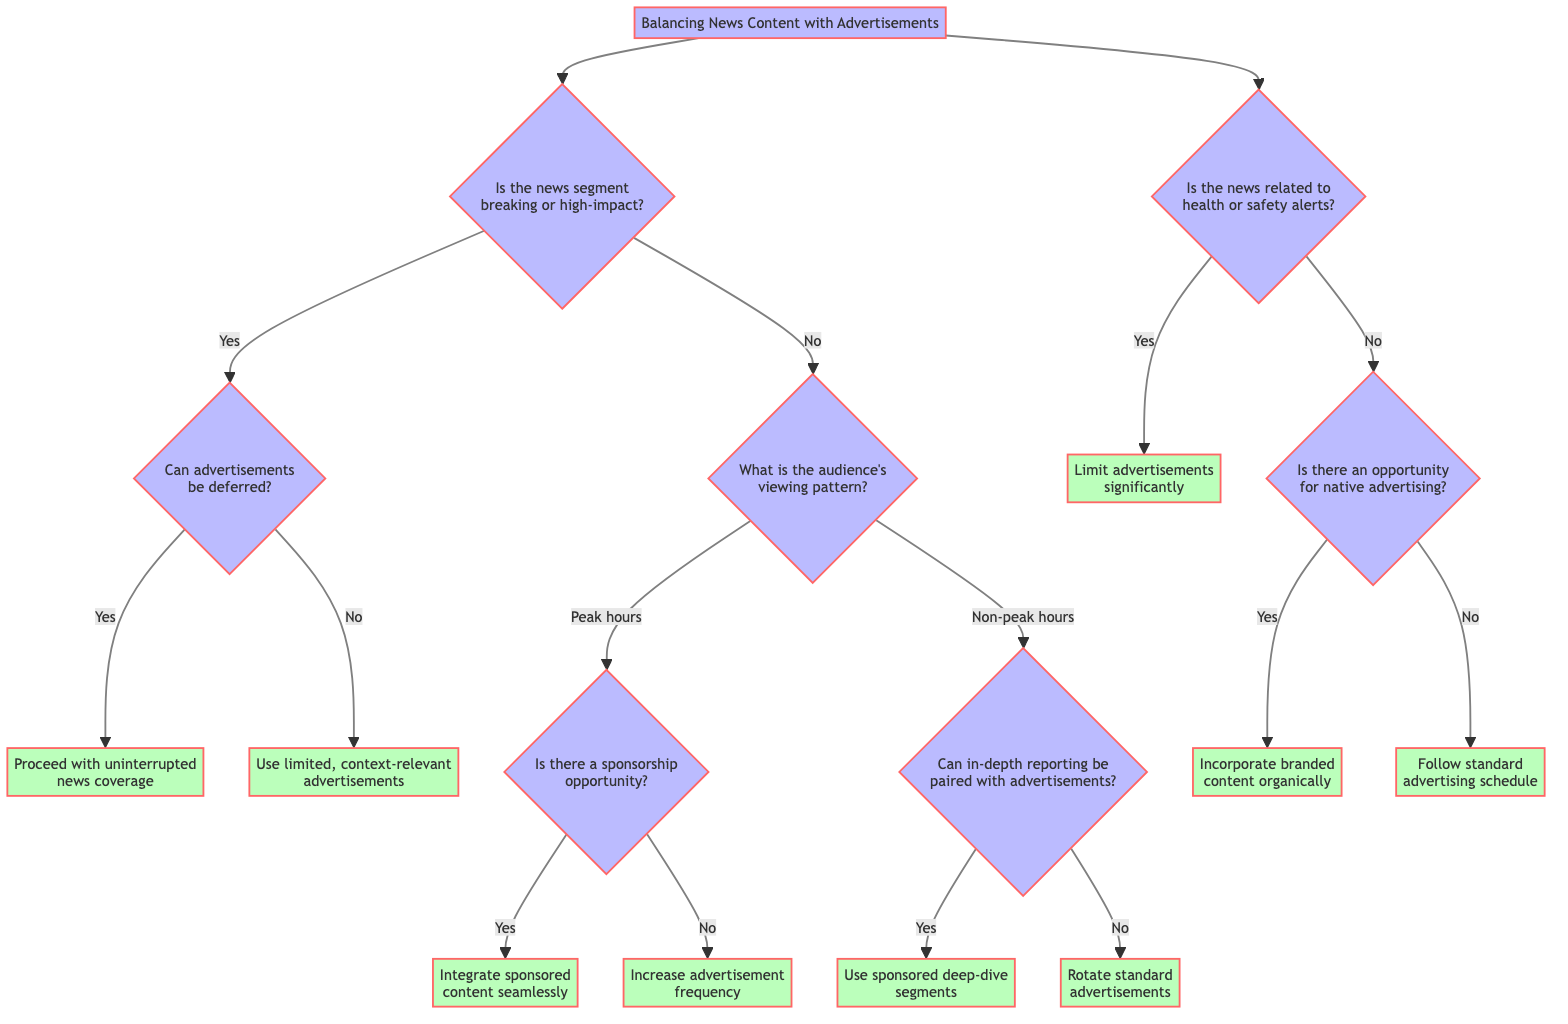Is the news segment breaking or high-impact? This is the first decision point in the diagram, determining whether the news segment is categorized as breaking or high-impact.
Answer: Yes/No What is the next question if the news segment is high-impact? If the news segment is categorized as high-impact, the next question posed is whether advertisements can be deferred.
Answer: Can advertisements be deferred? How many main decision paths are illustrated in the diagram? The diagram presents two primary decision branches stemming from the first question, leading to various outcomes based on viewer patterns and content type.
Answer: Two What action should be taken if the news is related to health or safety alerts? The diagram indicates that if the news pertains to health or safety alerts, the suggested action is to limit advertisements significantly to maintain credibility.
Answer: Limit advertisements significantly If the audience is watching during peak hours and there is no sponsorship opportunity, what is the recommended action? In this scenario, the decision tree directs to increase advertisement frequency since the high viewership can be leveraged for greater revenue.
Answer: Increase advertisement frequency What is the follow-up action if in-depth reporting can be paired with advertisements? If it is determined that in-depth reporting can indeed be paired with advertisements, the action suggested in the diagram is to use sponsored deep-dive segments.
Answer: Use sponsored deep-dive segments What happens if advertisements cannot be deferred for high-impact news? In this case, the diagram recommends using limited, context-relevant advertisements to maintain viewer trust while still incorporating ads.
Answer: Use limited, context-relevant advertisements What kind of content should be incorporated if there is an opportunity for native advertising? Should native advertising be possible, the suggested action is to incorporate branded content organically within the news stories without disrupting flow.
Answer: Incorporate branded content organically 